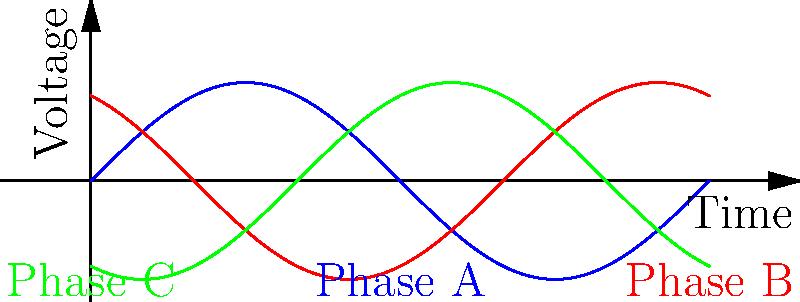In a three-phase power system, what is the phase difference between any two adjacent phases, and how does this relate to the concept of phase sequence? To understand the phase relationships in a three-phase power system:

1. Observe the waveform diagram: It shows three sinusoidal waves representing the three phases (A, B, and C) of a power system.

2. Phase difference calculation:
   - The total cycle is $2\pi$ radians or 360°.
   - There are three equally spaced phases.
   - Therefore, the phase difference = $\frac{2\pi}{3}$ radians or 120°.

3. Phase sequence:
   - The standard sequence is A-B-C (positive sequence).
   - Each phase leads the next by 120°.
   - Phase B leads Phase C by 120°, Phase C leads Phase A by 120°, and Phase A leads Phase B by 120°.

4. Importance in biochemistry:
   - Understanding phase relationships is crucial in designing and operating equipment that requires three-phase power, such as large centrifuges, spectrometers, or industrial-scale fermentation systems used in pharmaceutical research and production.

5. Relevance to research:
   - Proper phase sequencing ensures balanced operation of equipment, reducing wear and improving energy efficiency.
   - Incorrect phase relationships can lead to equipment malfunction or damage, potentially compromising research integrity or production quality.
Answer: 120° phase difference; determines positive sequence (A-B-C) for proper equipment operation. 